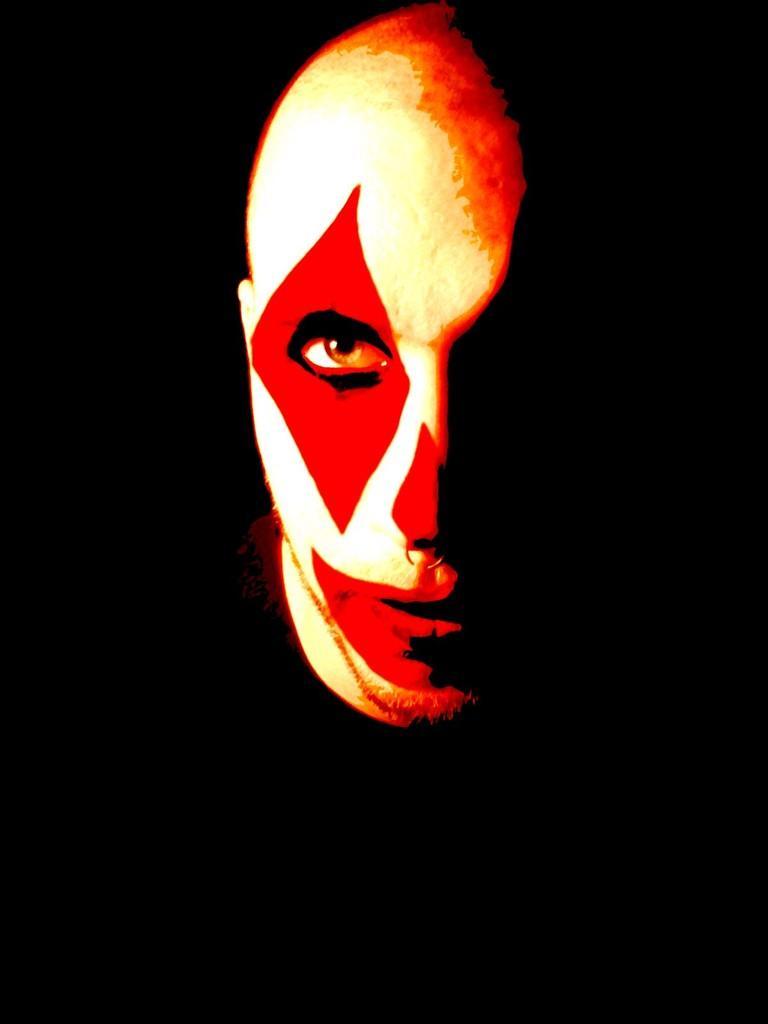Please provide a concise description of this image. In this image I can see the person's face which is red, orange and cream in color and I can see the black colored background. 